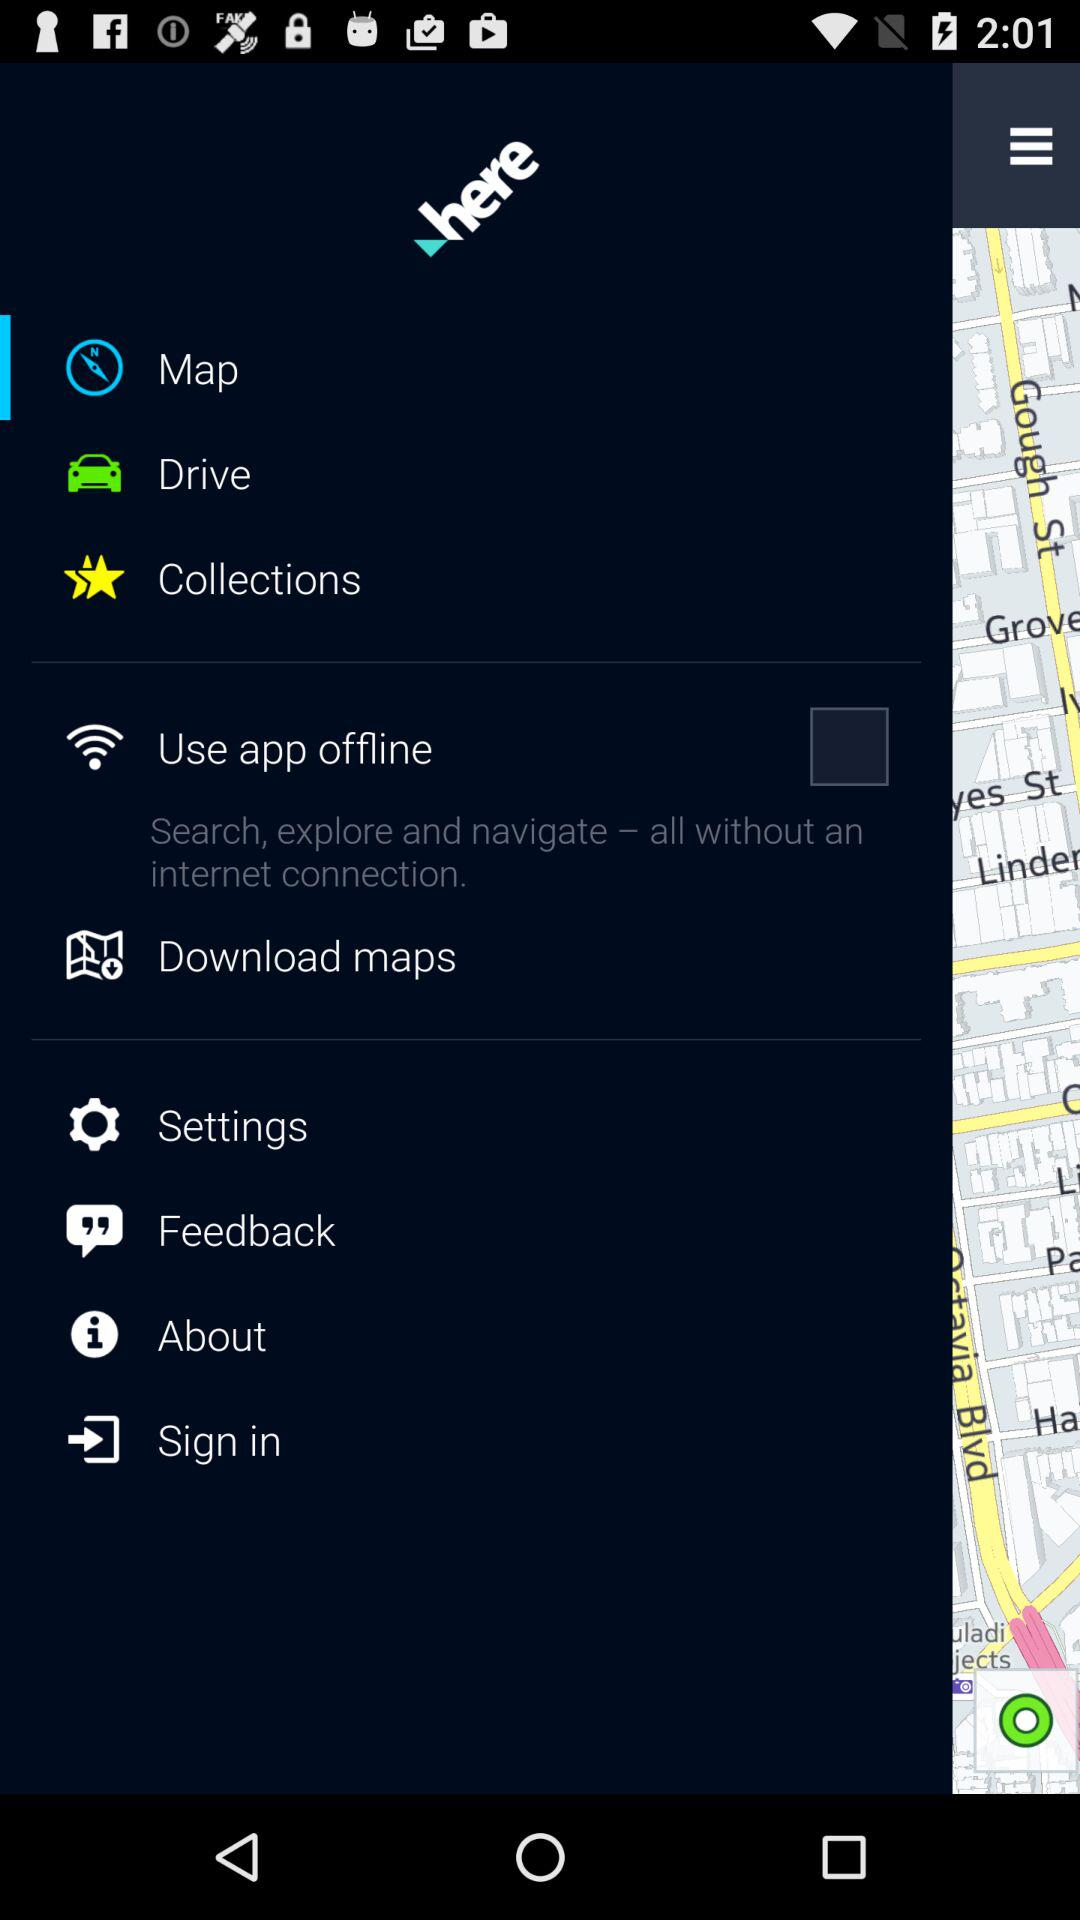How long will it take to get there?
When the provided information is insufficient, respond with <no answer>. <no answer> 